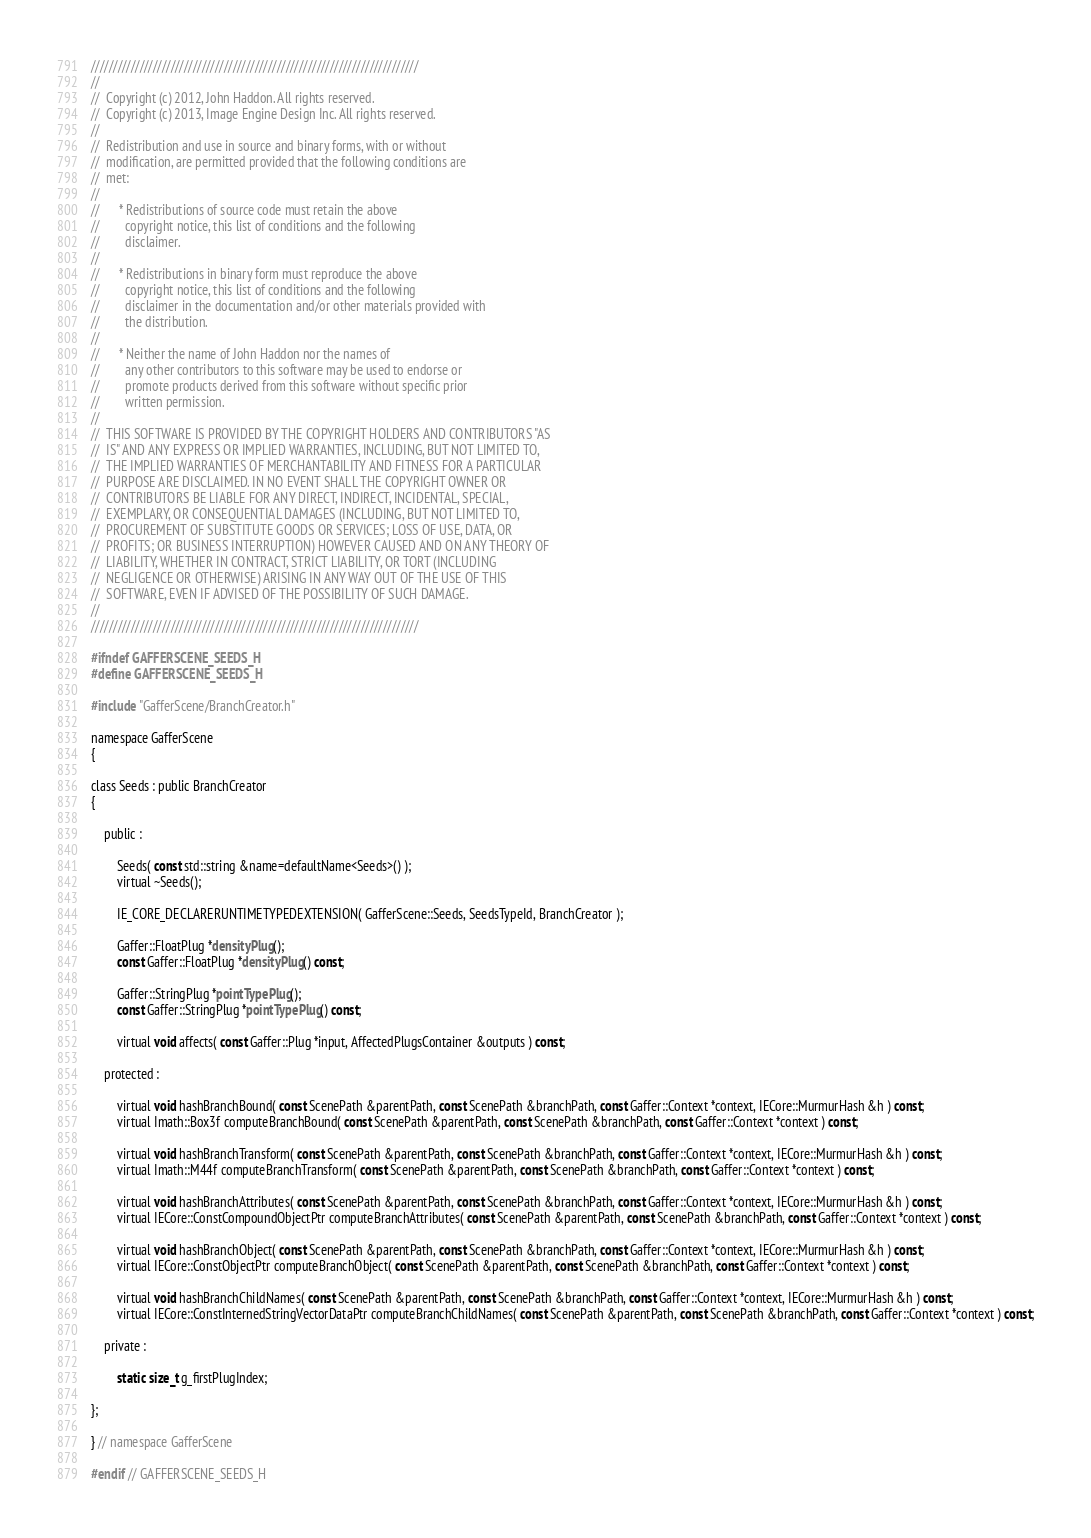Convert code to text. <code><loc_0><loc_0><loc_500><loc_500><_C_>//////////////////////////////////////////////////////////////////////////
//  
//  Copyright (c) 2012, John Haddon. All rights reserved.
//  Copyright (c) 2013, Image Engine Design Inc. All rights reserved.
//  
//  Redistribution and use in source and binary forms, with or without
//  modification, are permitted provided that the following conditions are
//  met:
//  
//      * Redistributions of source code must retain the above
//        copyright notice, this list of conditions and the following
//        disclaimer.
//  
//      * Redistributions in binary form must reproduce the above
//        copyright notice, this list of conditions and the following
//        disclaimer in the documentation and/or other materials provided with
//        the distribution.
//  
//      * Neither the name of John Haddon nor the names of
//        any other contributors to this software may be used to endorse or
//        promote products derived from this software without specific prior
//        written permission.
//  
//  THIS SOFTWARE IS PROVIDED BY THE COPYRIGHT HOLDERS AND CONTRIBUTORS "AS
//  IS" AND ANY EXPRESS OR IMPLIED WARRANTIES, INCLUDING, BUT NOT LIMITED TO,
//  THE IMPLIED WARRANTIES OF MERCHANTABILITY AND FITNESS FOR A PARTICULAR
//  PURPOSE ARE DISCLAIMED. IN NO EVENT SHALL THE COPYRIGHT OWNER OR
//  CONTRIBUTORS BE LIABLE FOR ANY DIRECT, INDIRECT, INCIDENTAL, SPECIAL,
//  EXEMPLARY, OR CONSEQUENTIAL DAMAGES (INCLUDING, BUT NOT LIMITED TO,
//  PROCUREMENT OF SUBSTITUTE GOODS OR SERVICES; LOSS OF USE, DATA, OR
//  PROFITS; OR BUSINESS INTERRUPTION) HOWEVER CAUSED AND ON ANY THEORY OF
//  LIABILITY, WHETHER IN CONTRACT, STRICT LIABILITY, OR TORT (INCLUDING
//  NEGLIGENCE OR OTHERWISE) ARISING IN ANY WAY OUT OF THE USE OF THIS
//  SOFTWARE, EVEN IF ADVISED OF THE POSSIBILITY OF SUCH DAMAGE.
//  
//////////////////////////////////////////////////////////////////////////

#ifndef GAFFERSCENE_SEEDS_H
#define GAFFERSCENE_SEEDS_H

#include "GafferScene/BranchCreator.h"

namespace GafferScene
{

class Seeds : public BranchCreator
{

	public :

		Seeds( const std::string &name=defaultName<Seeds>() );
		virtual ~Seeds();

		IE_CORE_DECLARERUNTIMETYPEDEXTENSION( GafferScene::Seeds, SeedsTypeId, BranchCreator );
		
		Gaffer::FloatPlug *densityPlug();
		const Gaffer::FloatPlug *densityPlug() const;
		
		Gaffer::StringPlug *pointTypePlug();
		const Gaffer::StringPlug *pointTypePlug() const;

		virtual void affects( const Gaffer::Plug *input, AffectedPlugsContainer &outputs ) const;

	protected :
	
		virtual void hashBranchBound( const ScenePath &parentPath, const ScenePath &branchPath, const Gaffer::Context *context, IECore::MurmurHash &h ) const;
		virtual Imath::Box3f computeBranchBound( const ScenePath &parentPath, const ScenePath &branchPath, const Gaffer::Context *context ) const;
		
		virtual void hashBranchTransform( const ScenePath &parentPath, const ScenePath &branchPath, const Gaffer::Context *context, IECore::MurmurHash &h ) const;
		virtual Imath::M44f computeBranchTransform( const ScenePath &parentPath, const ScenePath &branchPath, const Gaffer::Context *context ) const;

		virtual void hashBranchAttributes( const ScenePath &parentPath, const ScenePath &branchPath, const Gaffer::Context *context, IECore::MurmurHash &h ) const;
		virtual IECore::ConstCompoundObjectPtr computeBranchAttributes( const ScenePath &parentPath, const ScenePath &branchPath, const Gaffer::Context *context ) const;

		virtual void hashBranchObject( const ScenePath &parentPath, const ScenePath &branchPath, const Gaffer::Context *context, IECore::MurmurHash &h ) const;
		virtual IECore::ConstObjectPtr computeBranchObject( const ScenePath &parentPath, const ScenePath &branchPath, const Gaffer::Context *context ) const;
		
		virtual void hashBranchChildNames( const ScenePath &parentPath, const ScenePath &branchPath, const Gaffer::Context *context, IECore::MurmurHash &h ) const;
		virtual IECore::ConstInternedStringVectorDataPtr computeBranchChildNames( const ScenePath &parentPath, const ScenePath &branchPath, const Gaffer::Context *context ) const;

	private :
	
		static size_t g_firstPlugIndex;
		
};

} // namespace GafferScene

#endif // GAFFERSCENE_SEEDS_H
</code> 